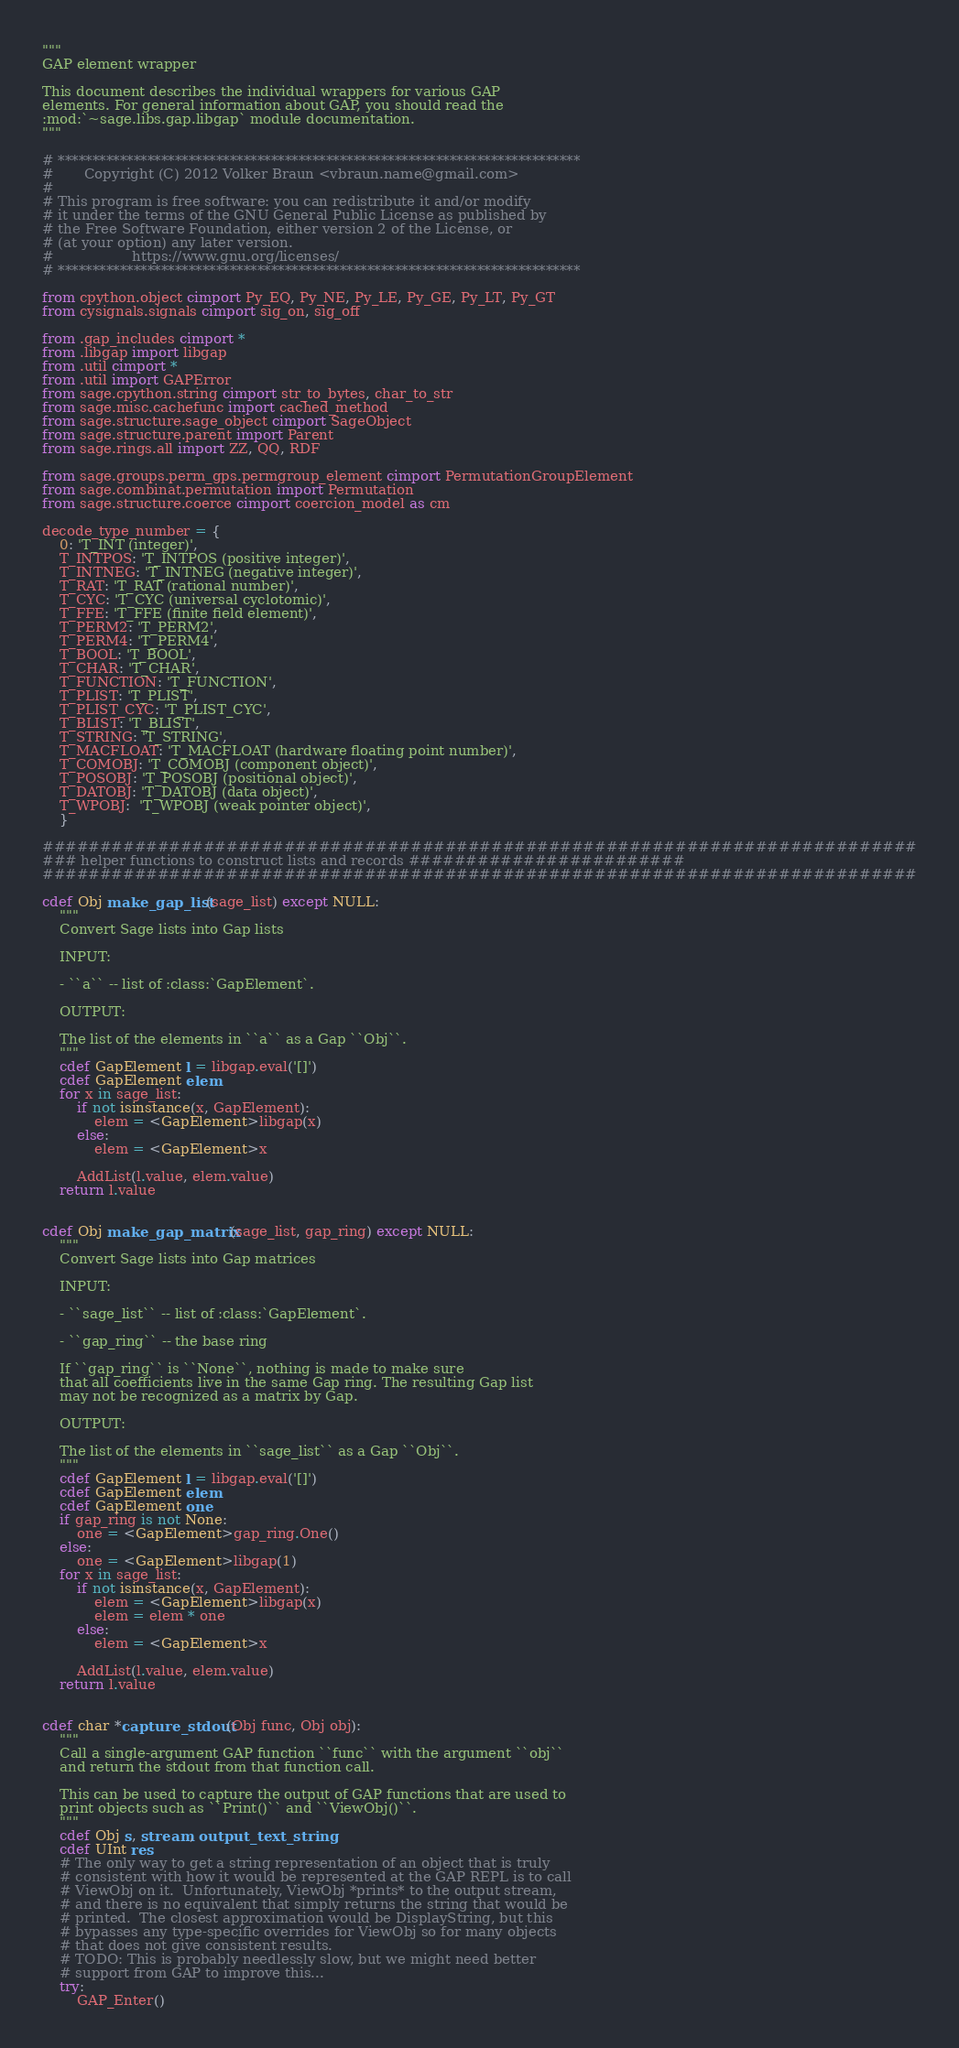<code> <loc_0><loc_0><loc_500><loc_500><_Cython_>"""
GAP element wrapper

This document describes the individual wrappers for various GAP
elements. For general information about GAP, you should read the
:mod:`~sage.libs.gap.libgap` module documentation.
"""

# ****************************************************************************
#       Copyright (C) 2012 Volker Braun <vbraun.name@gmail.com>
#
# This program is free software: you can redistribute it and/or modify
# it under the terms of the GNU General Public License as published by
# the Free Software Foundation, either version 2 of the License, or
# (at your option) any later version.
#                  https://www.gnu.org/licenses/
# ****************************************************************************

from cpython.object cimport Py_EQ, Py_NE, Py_LE, Py_GE, Py_LT, Py_GT
from cysignals.signals cimport sig_on, sig_off

from .gap_includes cimport *
from .libgap import libgap
from .util cimport *
from .util import GAPError
from sage.cpython.string cimport str_to_bytes, char_to_str
from sage.misc.cachefunc import cached_method
from sage.structure.sage_object cimport SageObject
from sage.structure.parent import Parent
from sage.rings.all import ZZ, QQ, RDF

from sage.groups.perm_gps.permgroup_element cimport PermutationGroupElement
from sage.combinat.permutation import Permutation
from sage.structure.coerce cimport coercion_model as cm

decode_type_number = {
    0: 'T_INT (integer)',
    T_INTPOS: 'T_INTPOS (positive integer)',
    T_INTNEG: 'T_INTNEG (negative integer)',
    T_RAT: 'T_RAT (rational number)',
    T_CYC: 'T_CYC (universal cyclotomic)',
    T_FFE: 'T_FFE (finite field element)',
    T_PERM2: 'T_PERM2',
    T_PERM4: 'T_PERM4',
    T_BOOL: 'T_BOOL',
    T_CHAR: 'T_CHAR',
    T_FUNCTION: 'T_FUNCTION',
    T_PLIST: 'T_PLIST',
    T_PLIST_CYC: 'T_PLIST_CYC',
    T_BLIST: 'T_BLIST',
    T_STRING: 'T_STRING',
    T_MACFLOAT: 'T_MACFLOAT (hardware floating point number)',
    T_COMOBJ: 'T_COMOBJ (component object)',
    T_POSOBJ: 'T_POSOBJ (positional object)',
    T_DATOBJ: 'T_DATOBJ (data object)',
    T_WPOBJ:  'T_WPOBJ (weak pointer object)',
    }

############################################################################
### helper functions to construct lists and records ########################
############################################################################

cdef Obj make_gap_list(sage_list) except NULL:
    """
    Convert Sage lists into Gap lists

    INPUT:

    - ``a`` -- list of :class:`GapElement`.

    OUTPUT:

    The list of the elements in ``a`` as a Gap ``Obj``.
    """
    cdef GapElement l = libgap.eval('[]')
    cdef GapElement elem
    for x in sage_list:
        if not isinstance(x, GapElement):
            elem = <GapElement>libgap(x)
        else:
            elem = <GapElement>x

        AddList(l.value, elem.value)
    return l.value


cdef Obj make_gap_matrix(sage_list, gap_ring) except NULL:
    """
    Convert Sage lists into Gap matrices

    INPUT:

    - ``sage_list`` -- list of :class:`GapElement`.

    - ``gap_ring`` -- the base ring

    If ``gap_ring`` is ``None``, nothing is made to make sure
    that all coefficients live in the same Gap ring. The resulting Gap list
    may not be recognized as a matrix by Gap.

    OUTPUT:

    The list of the elements in ``sage_list`` as a Gap ``Obj``.
    """
    cdef GapElement l = libgap.eval('[]')
    cdef GapElement elem
    cdef GapElement one
    if gap_ring is not None:
        one = <GapElement>gap_ring.One()
    else:
        one = <GapElement>libgap(1)
    for x in sage_list:
        if not isinstance(x, GapElement):
            elem = <GapElement>libgap(x)
            elem = elem * one
        else:
            elem = <GapElement>x

        AddList(l.value, elem.value)
    return l.value


cdef char *capture_stdout(Obj func, Obj obj):
    """
    Call a single-argument GAP function ``func`` with the argument ``obj``
    and return the stdout from that function call.

    This can be used to capture the output of GAP functions that are used to
    print objects such as ``Print()`` and ``ViewObj()``.
    """
    cdef Obj s, stream, output_text_string
    cdef UInt res
    # The only way to get a string representation of an object that is truly
    # consistent with how it would be represented at the GAP REPL is to call
    # ViewObj on it.  Unfortunately, ViewObj *prints* to the output stream,
    # and there is no equivalent that simply returns the string that would be
    # printed.  The closest approximation would be DisplayString, but this
    # bypasses any type-specific overrides for ViewObj so for many objects
    # that does not give consistent results.
    # TODO: This is probably needlessly slow, but we might need better
    # support from GAP to improve this...
    try:
        GAP_Enter()</code> 